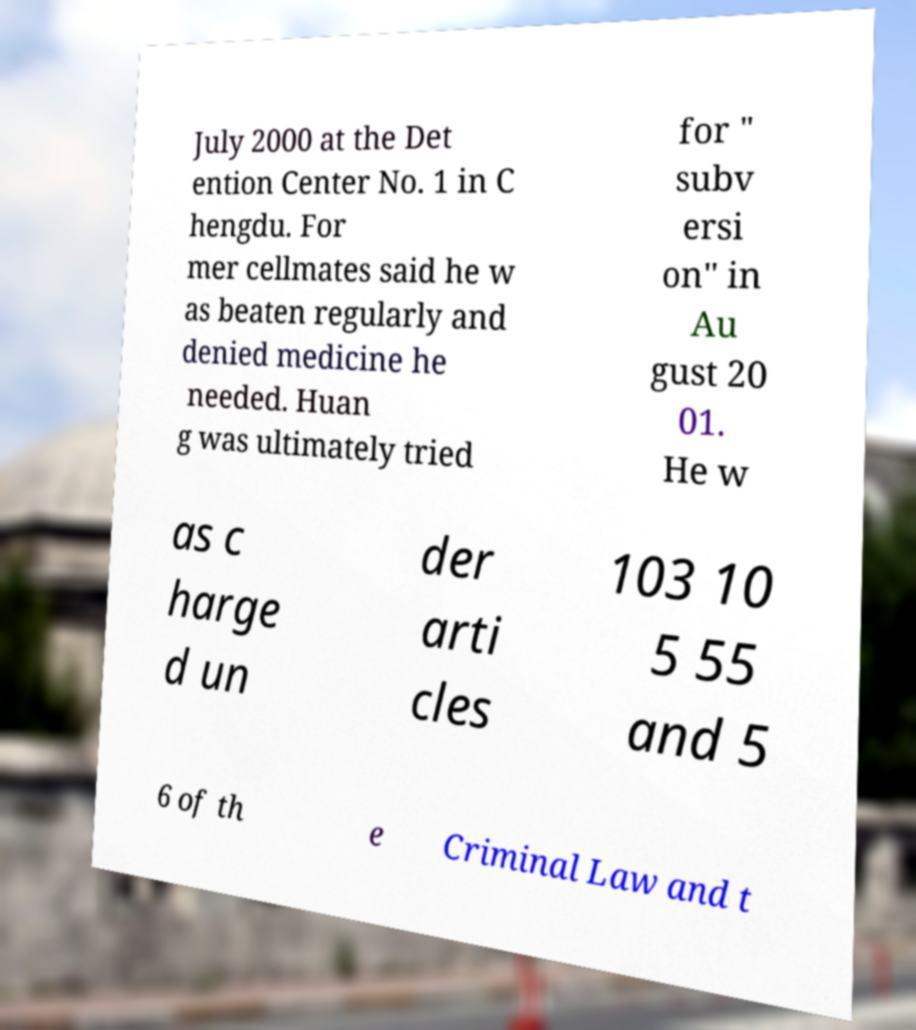I need the written content from this picture converted into text. Can you do that? July 2000 at the Det ention Center No. 1 in C hengdu. For mer cellmates said he w as beaten regularly and denied medicine he needed. Huan g was ultimately tried for " subv ersi on" in Au gust 20 01. He w as c harge d un der arti cles 103 10 5 55 and 5 6 of th e Criminal Law and t 